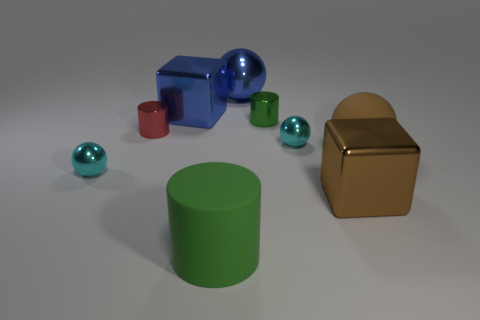What number of cyan metal spheres are behind the matte object to the right of the big cube that is in front of the big blue shiny cube?
Ensure brevity in your answer.  1. What shape is the green object that is the same material as the blue cube?
Make the answer very short. Cylinder. What material is the big blue block left of the big rubber object to the right of the big ball to the left of the large matte sphere?
Your answer should be compact. Metal. What number of things are cylinders behind the large brown rubber object or small purple rubber balls?
Your answer should be very brief. 2. What number of other things are there of the same shape as the tiny red thing?
Your answer should be very brief. 2. Are there more cyan metal balls that are to the right of the large brown cube than rubber spheres?
Your answer should be very brief. No. There is another rubber object that is the same shape as the tiny green thing; what is its size?
Give a very brief answer. Large. The large green matte thing is what shape?
Ensure brevity in your answer.  Cylinder. The brown metallic object that is the same size as the green matte cylinder is what shape?
Keep it short and to the point. Cube. What is the size of the brown cube that is the same material as the tiny red thing?
Ensure brevity in your answer.  Large. 